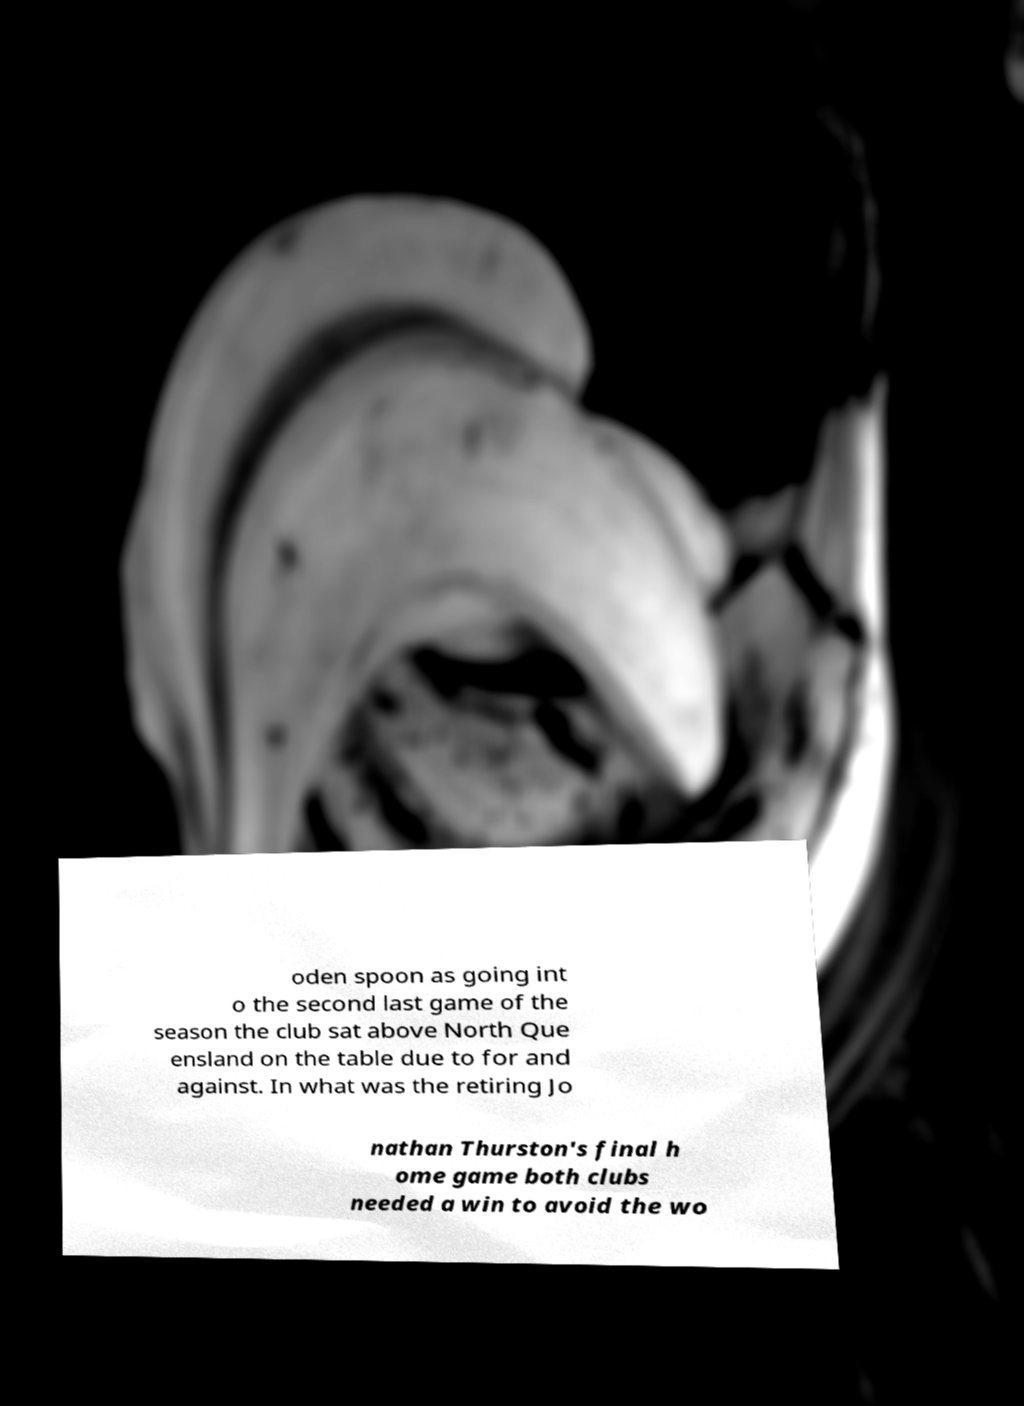Please read and relay the text visible in this image. What does it say? oden spoon as going int o the second last game of the season the club sat above North Que ensland on the table due to for and against. In what was the retiring Jo nathan Thurston's final h ome game both clubs needed a win to avoid the wo 